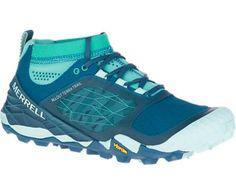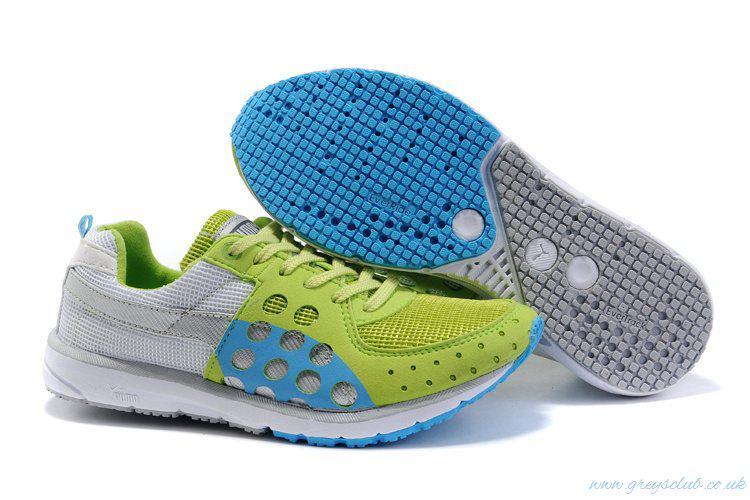The first image is the image on the left, the second image is the image on the right. For the images shown, is this caption "The left image contains a single right-facing blue sneaker, and the right image includes a shoe sole facing the camera." true? Answer yes or no. Yes. The first image is the image on the left, the second image is the image on the right. Given the left and right images, does the statement "There are fewer than four shoes depicted." hold true? Answer yes or no. Yes. 